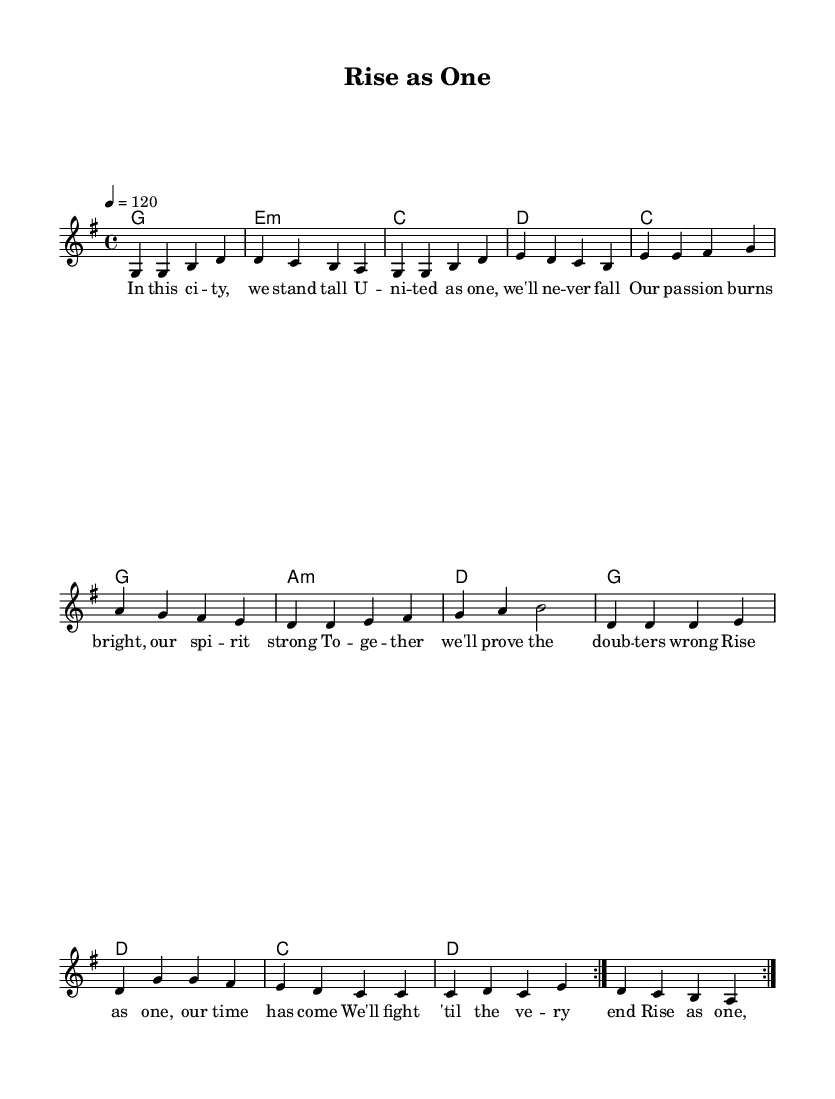What is the key signature of this music? The key signature indicated in the global section shows one sharp (F#), which corresponds to G major.
Answer: G major What is the time signature of this piece? The time signature is noted as 4/4, which means there are four beats in each measure.
Answer: 4/4 What is the tempo marking for the song? The tempo indication in the global section states "4 = 120", meaning the quarter note is to be played at a speed of 120 beats per minute.
Answer: 120 How many measures are in the repeated sections of the melody? Each repeat of the melody consists of 8 measures, and since there are 2 volta repeats, the total measures that are played twice is 8.
Answer: 8 What is the main theme in the lyrics of this anthem? The lyrics convey themes of unity, resilience, and strength, encouraging listeners to rise together as a team.
Answer: Unity How many chords are present in the harmonies section? Looking closely at the chord names provided, there are 6 unique chords that repeat during the progression.
Answer: 6 What is the emotional message conveyed through the lyrics? The lyrics promote motivation and courage, urging supporters to stand strong and believe in their team's potential for victory.
Answer: Motivation 